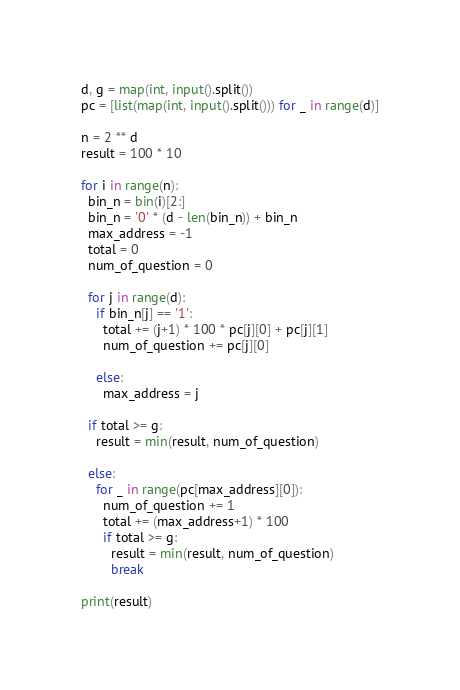Convert code to text. <code><loc_0><loc_0><loc_500><loc_500><_Python_>d, g = map(int, input().split())
pc = [list(map(int, input().split())) for _ in range(d)]

n = 2 ** d
result = 100 * 10

for i in range(n):
  bin_n = bin(i)[2:]
  bin_n = '0' * (d - len(bin_n)) + bin_n
  max_address = -1
  total = 0
  num_of_question = 0

  for j in range(d):
    if bin_n[j] == '1':
      total += (j+1) * 100 * pc[j][0] + pc[j][1]
      num_of_question += pc[j][0]
    
    else:
      max_address = j
  
  if total >= g:
    result = min(result, num_of_question)
  
  else:
    for _ in range(pc[max_address][0]):
      num_of_question += 1
      total += (max_address+1) * 100
      if total >= g:
        result = min(result, num_of_question)
        break

print(result)</code> 